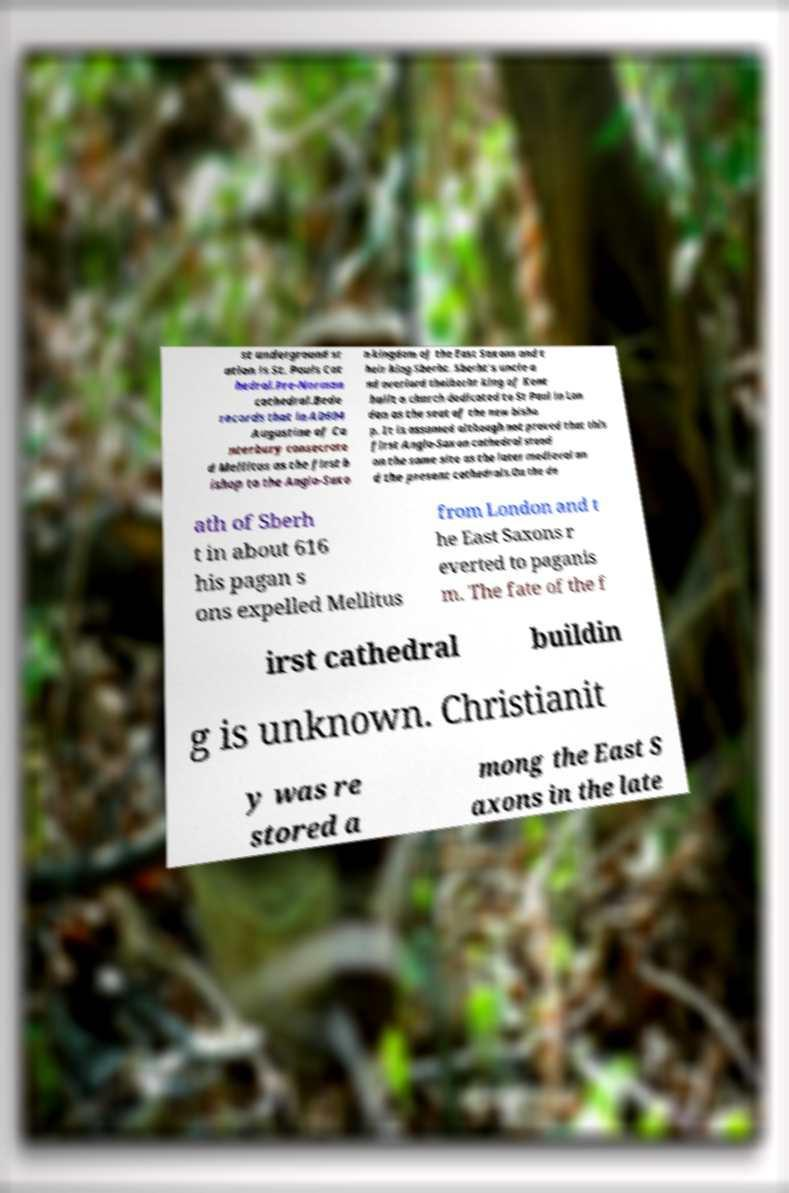Could you extract and type out the text from this image? st underground st ation is St. Pauls Cat hedral.Pre-Norman cathedral.Bede records that in AD604 Augustine of Ca nterbury consecrate d Mellitus as the first b ishop to the Anglo-Saxo n kingdom of the East Saxons and t heir king Sberht. Sberht's uncle a nd overlord thelberht king of Kent built a church dedicated to St Paul in Lon don as the seat of the new bisho p. It is assumed although not proved that this first Anglo-Saxon cathedral stood on the same site as the later medieval an d the present cathedrals.On the de ath of Sberh t in about 616 his pagan s ons expelled Mellitus from London and t he East Saxons r everted to paganis m. The fate of the f irst cathedral buildin g is unknown. Christianit y was re stored a mong the East S axons in the late 